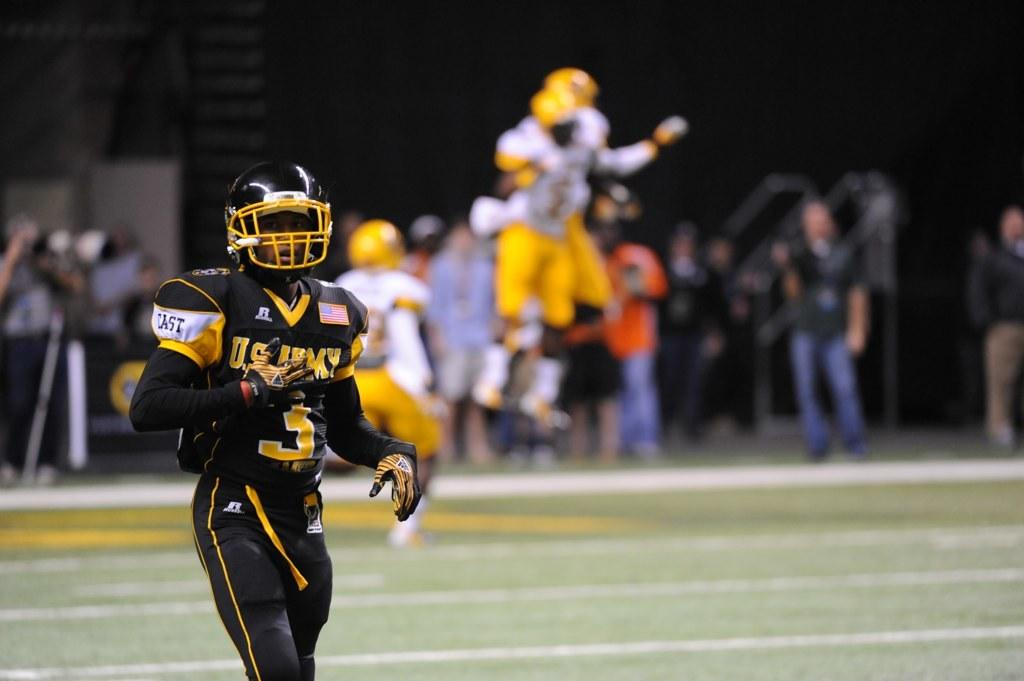What is the position of the person in the image? There is a person on the ground in the image. What protective gear is the person wearing? The person is wearing a helmet. What can be seen in the background of the image? There is a group of people and objects visible in the background of the image. How would you describe the clarity of the background in the image? The background is blurry. How many cats are visible in the image? There are no cats present in the image. What type of tears can be seen on the person's face in the image? There is no indication of crying or tears on the person's face in the image. 